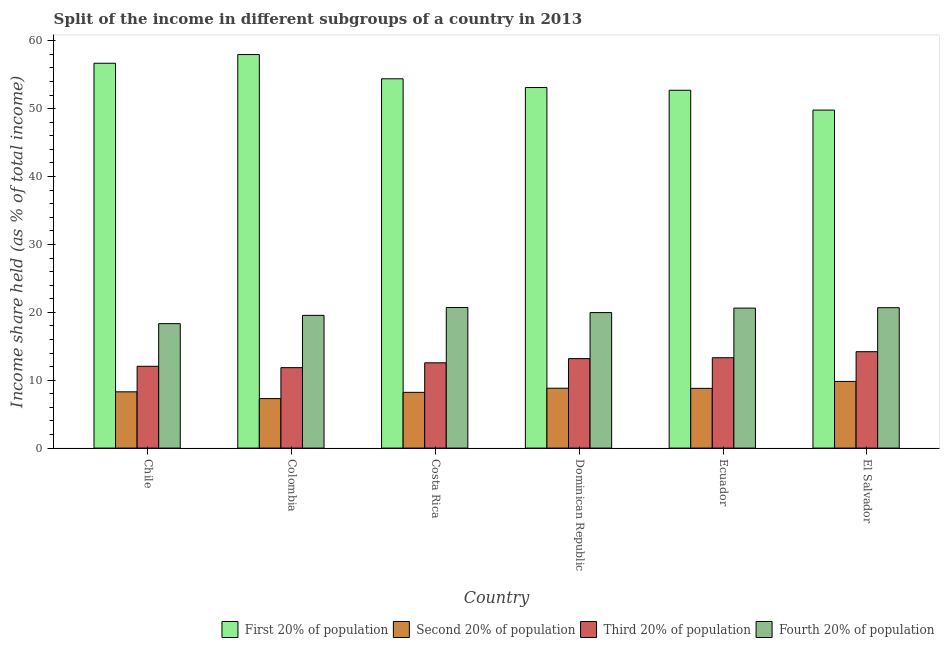Are the number of bars on each tick of the X-axis equal?
Keep it short and to the point. Yes. What is the label of the 4th group of bars from the left?
Ensure brevity in your answer.  Dominican Republic. What is the share of the income held by fourth 20% of the population in Costa Rica?
Ensure brevity in your answer.  20.71. Across all countries, what is the maximum share of the income held by second 20% of the population?
Your answer should be very brief. 9.82. Across all countries, what is the minimum share of the income held by first 20% of the population?
Keep it short and to the point. 49.79. In which country was the share of the income held by second 20% of the population maximum?
Offer a very short reply. El Salvador. What is the total share of the income held by third 20% of the population in the graph?
Provide a succinct answer. 77.15. What is the difference between the share of the income held by third 20% of the population in Ecuador and that in El Salvador?
Provide a short and direct response. -0.89. What is the difference between the share of the income held by first 20% of the population in Costa Rica and the share of the income held by second 20% of the population in El Salvador?
Your answer should be compact. 44.58. What is the average share of the income held by second 20% of the population per country?
Your response must be concise. 8.54. What is the difference between the share of the income held by fourth 20% of the population and share of the income held by first 20% of the population in Chile?
Keep it short and to the point. -38.36. What is the ratio of the share of the income held by third 20% of the population in Chile to that in Colombia?
Offer a terse response. 1.02. What is the difference between the highest and the second highest share of the income held by first 20% of the population?
Your answer should be compact. 1.28. What is the difference between the highest and the lowest share of the income held by third 20% of the population?
Ensure brevity in your answer.  2.35. In how many countries, is the share of the income held by fourth 20% of the population greater than the average share of the income held by fourth 20% of the population taken over all countries?
Your answer should be compact. 3. Is the sum of the share of the income held by second 20% of the population in Costa Rica and Ecuador greater than the maximum share of the income held by third 20% of the population across all countries?
Your answer should be very brief. Yes. Is it the case that in every country, the sum of the share of the income held by second 20% of the population and share of the income held by fourth 20% of the population is greater than the sum of share of the income held by first 20% of the population and share of the income held by third 20% of the population?
Give a very brief answer. Yes. What does the 4th bar from the left in El Salvador represents?
Provide a short and direct response. Fourth 20% of population. What does the 4th bar from the right in Ecuador represents?
Keep it short and to the point. First 20% of population. Is it the case that in every country, the sum of the share of the income held by first 20% of the population and share of the income held by second 20% of the population is greater than the share of the income held by third 20% of the population?
Give a very brief answer. Yes. Are all the bars in the graph horizontal?
Make the answer very short. No. How many countries are there in the graph?
Provide a succinct answer. 6. Does the graph contain any zero values?
Give a very brief answer. No. Does the graph contain grids?
Your answer should be very brief. No. How many legend labels are there?
Provide a short and direct response. 4. What is the title of the graph?
Provide a succinct answer. Split of the income in different subgroups of a country in 2013. What is the label or title of the X-axis?
Offer a very short reply. Country. What is the label or title of the Y-axis?
Provide a succinct answer. Income share held (as % of total income). What is the Income share held (as % of total income) in First 20% of population in Chile?
Ensure brevity in your answer.  56.69. What is the Income share held (as % of total income) of Second 20% of population in Chile?
Ensure brevity in your answer.  8.29. What is the Income share held (as % of total income) of Third 20% of population in Chile?
Ensure brevity in your answer.  12.05. What is the Income share held (as % of total income) of Fourth 20% of population in Chile?
Provide a short and direct response. 18.33. What is the Income share held (as % of total income) of First 20% of population in Colombia?
Offer a terse response. 57.97. What is the Income share held (as % of total income) of Second 20% of population in Colombia?
Your response must be concise. 7.29. What is the Income share held (as % of total income) of Third 20% of population in Colombia?
Provide a short and direct response. 11.85. What is the Income share held (as % of total income) of Fourth 20% of population in Colombia?
Give a very brief answer. 19.55. What is the Income share held (as % of total income) of First 20% of population in Costa Rica?
Ensure brevity in your answer.  54.4. What is the Income share held (as % of total income) in Second 20% of population in Costa Rica?
Your response must be concise. 8.21. What is the Income share held (as % of total income) in Third 20% of population in Costa Rica?
Your answer should be very brief. 12.56. What is the Income share held (as % of total income) of Fourth 20% of population in Costa Rica?
Your answer should be compact. 20.71. What is the Income share held (as % of total income) in First 20% of population in Dominican Republic?
Keep it short and to the point. 53.11. What is the Income share held (as % of total income) in Second 20% of population in Dominican Republic?
Keep it short and to the point. 8.82. What is the Income share held (as % of total income) of Third 20% of population in Dominican Republic?
Ensure brevity in your answer.  13.18. What is the Income share held (as % of total income) in Fourth 20% of population in Dominican Republic?
Give a very brief answer. 19.96. What is the Income share held (as % of total income) of First 20% of population in Ecuador?
Offer a very short reply. 52.71. What is the Income share held (as % of total income) of Third 20% of population in Ecuador?
Give a very brief answer. 13.31. What is the Income share held (as % of total income) in Fourth 20% of population in Ecuador?
Your answer should be compact. 20.62. What is the Income share held (as % of total income) of First 20% of population in El Salvador?
Offer a very short reply. 49.79. What is the Income share held (as % of total income) of Second 20% of population in El Salvador?
Give a very brief answer. 9.82. What is the Income share held (as % of total income) of Fourth 20% of population in El Salvador?
Your response must be concise. 20.68. Across all countries, what is the maximum Income share held (as % of total income) in First 20% of population?
Your answer should be compact. 57.97. Across all countries, what is the maximum Income share held (as % of total income) of Second 20% of population?
Make the answer very short. 9.82. Across all countries, what is the maximum Income share held (as % of total income) in Fourth 20% of population?
Ensure brevity in your answer.  20.71. Across all countries, what is the minimum Income share held (as % of total income) of First 20% of population?
Make the answer very short. 49.79. Across all countries, what is the minimum Income share held (as % of total income) of Second 20% of population?
Ensure brevity in your answer.  7.29. Across all countries, what is the minimum Income share held (as % of total income) of Third 20% of population?
Your answer should be very brief. 11.85. Across all countries, what is the minimum Income share held (as % of total income) of Fourth 20% of population?
Give a very brief answer. 18.33. What is the total Income share held (as % of total income) of First 20% of population in the graph?
Your answer should be very brief. 324.67. What is the total Income share held (as % of total income) of Second 20% of population in the graph?
Give a very brief answer. 51.23. What is the total Income share held (as % of total income) in Third 20% of population in the graph?
Offer a very short reply. 77.15. What is the total Income share held (as % of total income) of Fourth 20% of population in the graph?
Your answer should be very brief. 119.85. What is the difference between the Income share held (as % of total income) of First 20% of population in Chile and that in Colombia?
Give a very brief answer. -1.28. What is the difference between the Income share held (as % of total income) in Third 20% of population in Chile and that in Colombia?
Your answer should be compact. 0.2. What is the difference between the Income share held (as % of total income) of Fourth 20% of population in Chile and that in Colombia?
Your answer should be very brief. -1.22. What is the difference between the Income share held (as % of total income) of First 20% of population in Chile and that in Costa Rica?
Offer a terse response. 2.29. What is the difference between the Income share held (as % of total income) in Second 20% of population in Chile and that in Costa Rica?
Provide a succinct answer. 0.08. What is the difference between the Income share held (as % of total income) in Third 20% of population in Chile and that in Costa Rica?
Provide a succinct answer. -0.51. What is the difference between the Income share held (as % of total income) in Fourth 20% of population in Chile and that in Costa Rica?
Offer a very short reply. -2.38. What is the difference between the Income share held (as % of total income) of First 20% of population in Chile and that in Dominican Republic?
Your answer should be compact. 3.58. What is the difference between the Income share held (as % of total income) of Second 20% of population in Chile and that in Dominican Republic?
Your answer should be very brief. -0.53. What is the difference between the Income share held (as % of total income) in Third 20% of population in Chile and that in Dominican Republic?
Give a very brief answer. -1.13. What is the difference between the Income share held (as % of total income) of Fourth 20% of population in Chile and that in Dominican Republic?
Provide a succinct answer. -1.63. What is the difference between the Income share held (as % of total income) in First 20% of population in Chile and that in Ecuador?
Keep it short and to the point. 3.98. What is the difference between the Income share held (as % of total income) of Second 20% of population in Chile and that in Ecuador?
Your answer should be compact. -0.51. What is the difference between the Income share held (as % of total income) in Third 20% of population in Chile and that in Ecuador?
Your response must be concise. -1.26. What is the difference between the Income share held (as % of total income) in Fourth 20% of population in Chile and that in Ecuador?
Your answer should be compact. -2.29. What is the difference between the Income share held (as % of total income) of Second 20% of population in Chile and that in El Salvador?
Make the answer very short. -1.53. What is the difference between the Income share held (as % of total income) in Third 20% of population in Chile and that in El Salvador?
Offer a very short reply. -2.15. What is the difference between the Income share held (as % of total income) in Fourth 20% of population in Chile and that in El Salvador?
Your answer should be very brief. -2.35. What is the difference between the Income share held (as % of total income) in First 20% of population in Colombia and that in Costa Rica?
Make the answer very short. 3.57. What is the difference between the Income share held (as % of total income) in Second 20% of population in Colombia and that in Costa Rica?
Offer a very short reply. -0.92. What is the difference between the Income share held (as % of total income) of Third 20% of population in Colombia and that in Costa Rica?
Your answer should be compact. -0.71. What is the difference between the Income share held (as % of total income) in Fourth 20% of population in Colombia and that in Costa Rica?
Your response must be concise. -1.16. What is the difference between the Income share held (as % of total income) of First 20% of population in Colombia and that in Dominican Republic?
Offer a very short reply. 4.86. What is the difference between the Income share held (as % of total income) in Second 20% of population in Colombia and that in Dominican Republic?
Provide a succinct answer. -1.53. What is the difference between the Income share held (as % of total income) of Third 20% of population in Colombia and that in Dominican Republic?
Make the answer very short. -1.33. What is the difference between the Income share held (as % of total income) in Fourth 20% of population in Colombia and that in Dominican Republic?
Your answer should be compact. -0.41. What is the difference between the Income share held (as % of total income) in First 20% of population in Colombia and that in Ecuador?
Make the answer very short. 5.26. What is the difference between the Income share held (as % of total income) in Second 20% of population in Colombia and that in Ecuador?
Provide a succinct answer. -1.51. What is the difference between the Income share held (as % of total income) of Third 20% of population in Colombia and that in Ecuador?
Offer a very short reply. -1.46. What is the difference between the Income share held (as % of total income) in Fourth 20% of population in Colombia and that in Ecuador?
Provide a short and direct response. -1.07. What is the difference between the Income share held (as % of total income) of First 20% of population in Colombia and that in El Salvador?
Provide a short and direct response. 8.18. What is the difference between the Income share held (as % of total income) in Second 20% of population in Colombia and that in El Salvador?
Make the answer very short. -2.53. What is the difference between the Income share held (as % of total income) in Third 20% of population in Colombia and that in El Salvador?
Your answer should be compact. -2.35. What is the difference between the Income share held (as % of total income) of Fourth 20% of population in Colombia and that in El Salvador?
Give a very brief answer. -1.13. What is the difference between the Income share held (as % of total income) of First 20% of population in Costa Rica and that in Dominican Republic?
Your answer should be compact. 1.29. What is the difference between the Income share held (as % of total income) in Second 20% of population in Costa Rica and that in Dominican Republic?
Offer a terse response. -0.61. What is the difference between the Income share held (as % of total income) in Third 20% of population in Costa Rica and that in Dominican Republic?
Provide a short and direct response. -0.62. What is the difference between the Income share held (as % of total income) in Fourth 20% of population in Costa Rica and that in Dominican Republic?
Make the answer very short. 0.75. What is the difference between the Income share held (as % of total income) in First 20% of population in Costa Rica and that in Ecuador?
Offer a terse response. 1.69. What is the difference between the Income share held (as % of total income) of Second 20% of population in Costa Rica and that in Ecuador?
Provide a short and direct response. -0.59. What is the difference between the Income share held (as % of total income) in Third 20% of population in Costa Rica and that in Ecuador?
Ensure brevity in your answer.  -0.75. What is the difference between the Income share held (as % of total income) of Fourth 20% of population in Costa Rica and that in Ecuador?
Provide a succinct answer. 0.09. What is the difference between the Income share held (as % of total income) of First 20% of population in Costa Rica and that in El Salvador?
Provide a succinct answer. 4.61. What is the difference between the Income share held (as % of total income) in Second 20% of population in Costa Rica and that in El Salvador?
Offer a terse response. -1.61. What is the difference between the Income share held (as % of total income) in Third 20% of population in Costa Rica and that in El Salvador?
Offer a terse response. -1.64. What is the difference between the Income share held (as % of total income) in First 20% of population in Dominican Republic and that in Ecuador?
Offer a terse response. 0.4. What is the difference between the Income share held (as % of total income) of Second 20% of population in Dominican Republic and that in Ecuador?
Ensure brevity in your answer.  0.02. What is the difference between the Income share held (as % of total income) in Third 20% of population in Dominican Republic and that in Ecuador?
Offer a very short reply. -0.13. What is the difference between the Income share held (as % of total income) in Fourth 20% of population in Dominican Republic and that in Ecuador?
Give a very brief answer. -0.66. What is the difference between the Income share held (as % of total income) of First 20% of population in Dominican Republic and that in El Salvador?
Provide a succinct answer. 3.32. What is the difference between the Income share held (as % of total income) of Third 20% of population in Dominican Republic and that in El Salvador?
Offer a very short reply. -1.02. What is the difference between the Income share held (as % of total income) in Fourth 20% of population in Dominican Republic and that in El Salvador?
Your answer should be compact. -0.72. What is the difference between the Income share held (as % of total income) in First 20% of population in Ecuador and that in El Salvador?
Keep it short and to the point. 2.92. What is the difference between the Income share held (as % of total income) in Second 20% of population in Ecuador and that in El Salvador?
Offer a very short reply. -1.02. What is the difference between the Income share held (as % of total income) in Third 20% of population in Ecuador and that in El Salvador?
Offer a very short reply. -0.89. What is the difference between the Income share held (as % of total income) of Fourth 20% of population in Ecuador and that in El Salvador?
Give a very brief answer. -0.06. What is the difference between the Income share held (as % of total income) of First 20% of population in Chile and the Income share held (as % of total income) of Second 20% of population in Colombia?
Make the answer very short. 49.4. What is the difference between the Income share held (as % of total income) of First 20% of population in Chile and the Income share held (as % of total income) of Third 20% of population in Colombia?
Your response must be concise. 44.84. What is the difference between the Income share held (as % of total income) in First 20% of population in Chile and the Income share held (as % of total income) in Fourth 20% of population in Colombia?
Your answer should be very brief. 37.14. What is the difference between the Income share held (as % of total income) in Second 20% of population in Chile and the Income share held (as % of total income) in Third 20% of population in Colombia?
Provide a succinct answer. -3.56. What is the difference between the Income share held (as % of total income) of Second 20% of population in Chile and the Income share held (as % of total income) of Fourth 20% of population in Colombia?
Offer a very short reply. -11.26. What is the difference between the Income share held (as % of total income) of Third 20% of population in Chile and the Income share held (as % of total income) of Fourth 20% of population in Colombia?
Your response must be concise. -7.5. What is the difference between the Income share held (as % of total income) in First 20% of population in Chile and the Income share held (as % of total income) in Second 20% of population in Costa Rica?
Offer a terse response. 48.48. What is the difference between the Income share held (as % of total income) of First 20% of population in Chile and the Income share held (as % of total income) of Third 20% of population in Costa Rica?
Your answer should be compact. 44.13. What is the difference between the Income share held (as % of total income) in First 20% of population in Chile and the Income share held (as % of total income) in Fourth 20% of population in Costa Rica?
Provide a short and direct response. 35.98. What is the difference between the Income share held (as % of total income) of Second 20% of population in Chile and the Income share held (as % of total income) of Third 20% of population in Costa Rica?
Keep it short and to the point. -4.27. What is the difference between the Income share held (as % of total income) in Second 20% of population in Chile and the Income share held (as % of total income) in Fourth 20% of population in Costa Rica?
Your answer should be very brief. -12.42. What is the difference between the Income share held (as % of total income) in Third 20% of population in Chile and the Income share held (as % of total income) in Fourth 20% of population in Costa Rica?
Your response must be concise. -8.66. What is the difference between the Income share held (as % of total income) of First 20% of population in Chile and the Income share held (as % of total income) of Second 20% of population in Dominican Republic?
Keep it short and to the point. 47.87. What is the difference between the Income share held (as % of total income) of First 20% of population in Chile and the Income share held (as % of total income) of Third 20% of population in Dominican Republic?
Provide a short and direct response. 43.51. What is the difference between the Income share held (as % of total income) in First 20% of population in Chile and the Income share held (as % of total income) in Fourth 20% of population in Dominican Republic?
Provide a succinct answer. 36.73. What is the difference between the Income share held (as % of total income) in Second 20% of population in Chile and the Income share held (as % of total income) in Third 20% of population in Dominican Republic?
Your response must be concise. -4.89. What is the difference between the Income share held (as % of total income) in Second 20% of population in Chile and the Income share held (as % of total income) in Fourth 20% of population in Dominican Republic?
Offer a very short reply. -11.67. What is the difference between the Income share held (as % of total income) of Third 20% of population in Chile and the Income share held (as % of total income) of Fourth 20% of population in Dominican Republic?
Offer a very short reply. -7.91. What is the difference between the Income share held (as % of total income) in First 20% of population in Chile and the Income share held (as % of total income) in Second 20% of population in Ecuador?
Make the answer very short. 47.89. What is the difference between the Income share held (as % of total income) in First 20% of population in Chile and the Income share held (as % of total income) in Third 20% of population in Ecuador?
Ensure brevity in your answer.  43.38. What is the difference between the Income share held (as % of total income) in First 20% of population in Chile and the Income share held (as % of total income) in Fourth 20% of population in Ecuador?
Keep it short and to the point. 36.07. What is the difference between the Income share held (as % of total income) of Second 20% of population in Chile and the Income share held (as % of total income) of Third 20% of population in Ecuador?
Your response must be concise. -5.02. What is the difference between the Income share held (as % of total income) of Second 20% of population in Chile and the Income share held (as % of total income) of Fourth 20% of population in Ecuador?
Provide a short and direct response. -12.33. What is the difference between the Income share held (as % of total income) of Third 20% of population in Chile and the Income share held (as % of total income) of Fourth 20% of population in Ecuador?
Your response must be concise. -8.57. What is the difference between the Income share held (as % of total income) of First 20% of population in Chile and the Income share held (as % of total income) of Second 20% of population in El Salvador?
Your answer should be compact. 46.87. What is the difference between the Income share held (as % of total income) in First 20% of population in Chile and the Income share held (as % of total income) in Third 20% of population in El Salvador?
Provide a short and direct response. 42.49. What is the difference between the Income share held (as % of total income) in First 20% of population in Chile and the Income share held (as % of total income) in Fourth 20% of population in El Salvador?
Offer a terse response. 36.01. What is the difference between the Income share held (as % of total income) of Second 20% of population in Chile and the Income share held (as % of total income) of Third 20% of population in El Salvador?
Your answer should be very brief. -5.91. What is the difference between the Income share held (as % of total income) of Second 20% of population in Chile and the Income share held (as % of total income) of Fourth 20% of population in El Salvador?
Your answer should be very brief. -12.39. What is the difference between the Income share held (as % of total income) in Third 20% of population in Chile and the Income share held (as % of total income) in Fourth 20% of population in El Salvador?
Provide a succinct answer. -8.63. What is the difference between the Income share held (as % of total income) in First 20% of population in Colombia and the Income share held (as % of total income) in Second 20% of population in Costa Rica?
Provide a short and direct response. 49.76. What is the difference between the Income share held (as % of total income) of First 20% of population in Colombia and the Income share held (as % of total income) of Third 20% of population in Costa Rica?
Offer a terse response. 45.41. What is the difference between the Income share held (as % of total income) in First 20% of population in Colombia and the Income share held (as % of total income) in Fourth 20% of population in Costa Rica?
Give a very brief answer. 37.26. What is the difference between the Income share held (as % of total income) of Second 20% of population in Colombia and the Income share held (as % of total income) of Third 20% of population in Costa Rica?
Keep it short and to the point. -5.27. What is the difference between the Income share held (as % of total income) of Second 20% of population in Colombia and the Income share held (as % of total income) of Fourth 20% of population in Costa Rica?
Ensure brevity in your answer.  -13.42. What is the difference between the Income share held (as % of total income) of Third 20% of population in Colombia and the Income share held (as % of total income) of Fourth 20% of population in Costa Rica?
Ensure brevity in your answer.  -8.86. What is the difference between the Income share held (as % of total income) in First 20% of population in Colombia and the Income share held (as % of total income) in Second 20% of population in Dominican Republic?
Provide a succinct answer. 49.15. What is the difference between the Income share held (as % of total income) of First 20% of population in Colombia and the Income share held (as % of total income) of Third 20% of population in Dominican Republic?
Offer a very short reply. 44.79. What is the difference between the Income share held (as % of total income) of First 20% of population in Colombia and the Income share held (as % of total income) of Fourth 20% of population in Dominican Republic?
Your response must be concise. 38.01. What is the difference between the Income share held (as % of total income) of Second 20% of population in Colombia and the Income share held (as % of total income) of Third 20% of population in Dominican Republic?
Your answer should be very brief. -5.89. What is the difference between the Income share held (as % of total income) of Second 20% of population in Colombia and the Income share held (as % of total income) of Fourth 20% of population in Dominican Republic?
Give a very brief answer. -12.67. What is the difference between the Income share held (as % of total income) of Third 20% of population in Colombia and the Income share held (as % of total income) of Fourth 20% of population in Dominican Republic?
Offer a very short reply. -8.11. What is the difference between the Income share held (as % of total income) in First 20% of population in Colombia and the Income share held (as % of total income) in Second 20% of population in Ecuador?
Your answer should be compact. 49.17. What is the difference between the Income share held (as % of total income) of First 20% of population in Colombia and the Income share held (as % of total income) of Third 20% of population in Ecuador?
Your response must be concise. 44.66. What is the difference between the Income share held (as % of total income) of First 20% of population in Colombia and the Income share held (as % of total income) of Fourth 20% of population in Ecuador?
Provide a short and direct response. 37.35. What is the difference between the Income share held (as % of total income) in Second 20% of population in Colombia and the Income share held (as % of total income) in Third 20% of population in Ecuador?
Offer a terse response. -6.02. What is the difference between the Income share held (as % of total income) of Second 20% of population in Colombia and the Income share held (as % of total income) of Fourth 20% of population in Ecuador?
Your answer should be compact. -13.33. What is the difference between the Income share held (as % of total income) of Third 20% of population in Colombia and the Income share held (as % of total income) of Fourth 20% of population in Ecuador?
Provide a short and direct response. -8.77. What is the difference between the Income share held (as % of total income) of First 20% of population in Colombia and the Income share held (as % of total income) of Second 20% of population in El Salvador?
Your response must be concise. 48.15. What is the difference between the Income share held (as % of total income) of First 20% of population in Colombia and the Income share held (as % of total income) of Third 20% of population in El Salvador?
Ensure brevity in your answer.  43.77. What is the difference between the Income share held (as % of total income) of First 20% of population in Colombia and the Income share held (as % of total income) of Fourth 20% of population in El Salvador?
Your answer should be compact. 37.29. What is the difference between the Income share held (as % of total income) in Second 20% of population in Colombia and the Income share held (as % of total income) in Third 20% of population in El Salvador?
Keep it short and to the point. -6.91. What is the difference between the Income share held (as % of total income) of Second 20% of population in Colombia and the Income share held (as % of total income) of Fourth 20% of population in El Salvador?
Ensure brevity in your answer.  -13.39. What is the difference between the Income share held (as % of total income) in Third 20% of population in Colombia and the Income share held (as % of total income) in Fourth 20% of population in El Salvador?
Give a very brief answer. -8.83. What is the difference between the Income share held (as % of total income) of First 20% of population in Costa Rica and the Income share held (as % of total income) of Second 20% of population in Dominican Republic?
Your response must be concise. 45.58. What is the difference between the Income share held (as % of total income) in First 20% of population in Costa Rica and the Income share held (as % of total income) in Third 20% of population in Dominican Republic?
Offer a terse response. 41.22. What is the difference between the Income share held (as % of total income) of First 20% of population in Costa Rica and the Income share held (as % of total income) of Fourth 20% of population in Dominican Republic?
Provide a succinct answer. 34.44. What is the difference between the Income share held (as % of total income) of Second 20% of population in Costa Rica and the Income share held (as % of total income) of Third 20% of population in Dominican Republic?
Make the answer very short. -4.97. What is the difference between the Income share held (as % of total income) in Second 20% of population in Costa Rica and the Income share held (as % of total income) in Fourth 20% of population in Dominican Republic?
Your response must be concise. -11.75. What is the difference between the Income share held (as % of total income) in Third 20% of population in Costa Rica and the Income share held (as % of total income) in Fourth 20% of population in Dominican Republic?
Give a very brief answer. -7.4. What is the difference between the Income share held (as % of total income) of First 20% of population in Costa Rica and the Income share held (as % of total income) of Second 20% of population in Ecuador?
Offer a very short reply. 45.6. What is the difference between the Income share held (as % of total income) in First 20% of population in Costa Rica and the Income share held (as % of total income) in Third 20% of population in Ecuador?
Keep it short and to the point. 41.09. What is the difference between the Income share held (as % of total income) of First 20% of population in Costa Rica and the Income share held (as % of total income) of Fourth 20% of population in Ecuador?
Make the answer very short. 33.78. What is the difference between the Income share held (as % of total income) in Second 20% of population in Costa Rica and the Income share held (as % of total income) in Third 20% of population in Ecuador?
Your answer should be very brief. -5.1. What is the difference between the Income share held (as % of total income) in Second 20% of population in Costa Rica and the Income share held (as % of total income) in Fourth 20% of population in Ecuador?
Provide a short and direct response. -12.41. What is the difference between the Income share held (as % of total income) in Third 20% of population in Costa Rica and the Income share held (as % of total income) in Fourth 20% of population in Ecuador?
Offer a terse response. -8.06. What is the difference between the Income share held (as % of total income) of First 20% of population in Costa Rica and the Income share held (as % of total income) of Second 20% of population in El Salvador?
Provide a short and direct response. 44.58. What is the difference between the Income share held (as % of total income) of First 20% of population in Costa Rica and the Income share held (as % of total income) of Third 20% of population in El Salvador?
Your answer should be compact. 40.2. What is the difference between the Income share held (as % of total income) of First 20% of population in Costa Rica and the Income share held (as % of total income) of Fourth 20% of population in El Salvador?
Your answer should be compact. 33.72. What is the difference between the Income share held (as % of total income) of Second 20% of population in Costa Rica and the Income share held (as % of total income) of Third 20% of population in El Salvador?
Your answer should be compact. -5.99. What is the difference between the Income share held (as % of total income) of Second 20% of population in Costa Rica and the Income share held (as % of total income) of Fourth 20% of population in El Salvador?
Provide a short and direct response. -12.47. What is the difference between the Income share held (as % of total income) of Third 20% of population in Costa Rica and the Income share held (as % of total income) of Fourth 20% of population in El Salvador?
Give a very brief answer. -8.12. What is the difference between the Income share held (as % of total income) of First 20% of population in Dominican Republic and the Income share held (as % of total income) of Second 20% of population in Ecuador?
Ensure brevity in your answer.  44.31. What is the difference between the Income share held (as % of total income) in First 20% of population in Dominican Republic and the Income share held (as % of total income) in Third 20% of population in Ecuador?
Make the answer very short. 39.8. What is the difference between the Income share held (as % of total income) in First 20% of population in Dominican Republic and the Income share held (as % of total income) in Fourth 20% of population in Ecuador?
Offer a terse response. 32.49. What is the difference between the Income share held (as % of total income) in Second 20% of population in Dominican Republic and the Income share held (as % of total income) in Third 20% of population in Ecuador?
Provide a short and direct response. -4.49. What is the difference between the Income share held (as % of total income) of Third 20% of population in Dominican Republic and the Income share held (as % of total income) of Fourth 20% of population in Ecuador?
Make the answer very short. -7.44. What is the difference between the Income share held (as % of total income) of First 20% of population in Dominican Republic and the Income share held (as % of total income) of Second 20% of population in El Salvador?
Offer a terse response. 43.29. What is the difference between the Income share held (as % of total income) of First 20% of population in Dominican Republic and the Income share held (as % of total income) of Third 20% of population in El Salvador?
Ensure brevity in your answer.  38.91. What is the difference between the Income share held (as % of total income) in First 20% of population in Dominican Republic and the Income share held (as % of total income) in Fourth 20% of population in El Salvador?
Offer a very short reply. 32.43. What is the difference between the Income share held (as % of total income) of Second 20% of population in Dominican Republic and the Income share held (as % of total income) of Third 20% of population in El Salvador?
Make the answer very short. -5.38. What is the difference between the Income share held (as % of total income) of Second 20% of population in Dominican Republic and the Income share held (as % of total income) of Fourth 20% of population in El Salvador?
Provide a short and direct response. -11.86. What is the difference between the Income share held (as % of total income) in Third 20% of population in Dominican Republic and the Income share held (as % of total income) in Fourth 20% of population in El Salvador?
Your answer should be compact. -7.5. What is the difference between the Income share held (as % of total income) in First 20% of population in Ecuador and the Income share held (as % of total income) in Second 20% of population in El Salvador?
Make the answer very short. 42.89. What is the difference between the Income share held (as % of total income) in First 20% of population in Ecuador and the Income share held (as % of total income) in Third 20% of population in El Salvador?
Keep it short and to the point. 38.51. What is the difference between the Income share held (as % of total income) of First 20% of population in Ecuador and the Income share held (as % of total income) of Fourth 20% of population in El Salvador?
Give a very brief answer. 32.03. What is the difference between the Income share held (as % of total income) of Second 20% of population in Ecuador and the Income share held (as % of total income) of Fourth 20% of population in El Salvador?
Offer a very short reply. -11.88. What is the difference between the Income share held (as % of total income) of Third 20% of population in Ecuador and the Income share held (as % of total income) of Fourth 20% of population in El Salvador?
Your response must be concise. -7.37. What is the average Income share held (as % of total income) of First 20% of population per country?
Your answer should be very brief. 54.11. What is the average Income share held (as % of total income) in Second 20% of population per country?
Your response must be concise. 8.54. What is the average Income share held (as % of total income) in Third 20% of population per country?
Offer a very short reply. 12.86. What is the average Income share held (as % of total income) of Fourth 20% of population per country?
Ensure brevity in your answer.  19.98. What is the difference between the Income share held (as % of total income) of First 20% of population and Income share held (as % of total income) of Second 20% of population in Chile?
Ensure brevity in your answer.  48.4. What is the difference between the Income share held (as % of total income) of First 20% of population and Income share held (as % of total income) of Third 20% of population in Chile?
Offer a very short reply. 44.64. What is the difference between the Income share held (as % of total income) in First 20% of population and Income share held (as % of total income) in Fourth 20% of population in Chile?
Give a very brief answer. 38.36. What is the difference between the Income share held (as % of total income) of Second 20% of population and Income share held (as % of total income) of Third 20% of population in Chile?
Offer a very short reply. -3.76. What is the difference between the Income share held (as % of total income) of Second 20% of population and Income share held (as % of total income) of Fourth 20% of population in Chile?
Provide a succinct answer. -10.04. What is the difference between the Income share held (as % of total income) of Third 20% of population and Income share held (as % of total income) of Fourth 20% of population in Chile?
Give a very brief answer. -6.28. What is the difference between the Income share held (as % of total income) in First 20% of population and Income share held (as % of total income) in Second 20% of population in Colombia?
Your response must be concise. 50.68. What is the difference between the Income share held (as % of total income) of First 20% of population and Income share held (as % of total income) of Third 20% of population in Colombia?
Give a very brief answer. 46.12. What is the difference between the Income share held (as % of total income) in First 20% of population and Income share held (as % of total income) in Fourth 20% of population in Colombia?
Provide a succinct answer. 38.42. What is the difference between the Income share held (as % of total income) in Second 20% of population and Income share held (as % of total income) in Third 20% of population in Colombia?
Provide a succinct answer. -4.56. What is the difference between the Income share held (as % of total income) in Second 20% of population and Income share held (as % of total income) in Fourth 20% of population in Colombia?
Your answer should be compact. -12.26. What is the difference between the Income share held (as % of total income) in Third 20% of population and Income share held (as % of total income) in Fourth 20% of population in Colombia?
Keep it short and to the point. -7.7. What is the difference between the Income share held (as % of total income) in First 20% of population and Income share held (as % of total income) in Second 20% of population in Costa Rica?
Your response must be concise. 46.19. What is the difference between the Income share held (as % of total income) of First 20% of population and Income share held (as % of total income) of Third 20% of population in Costa Rica?
Offer a very short reply. 41.84. What is the difference between the Income share held (as % of total income) of First 20% of population and Income share held (as % of total income) of Fourth 20% of population in Costa Rica?
Provide a succinct answer. 33.69. What is the difference between the Income share held (as % of total income) in Second 20% of population and Income share held (as % of total income) in Third 20% of population in Costa Rica?
Your answer should be very brief. -4.35. What is the difference between the Income share held (as % of total income) of Third 20% of population and Income share held (as % of total income) of Fourth 20% of population in Costa Rica?
Offer a very short reply. -8.15. What is the difference between the Income share held (as % of total income) in First 20% of population and Income share held (as % of total income) in Second 20% of population in Dominican Republic?
Your response must be concise. 44.29. What is the difference between the Income share held (as % of total income) in First 20% of population and Income share held (as % of total income) in Third 20% of population in Dominican Republic?
Provide a short and direct response. 39.93. What is the difference between the Income share held (as % of total income) in First 20% of population and Income share held (as % of total income) in Fourth 20% of population in Dominican Republic?
Your answer should be compact. 33.15. What is the difference between the Income share held (as % of total income) in Second 20% of population and Income share held (as % of total income) in Third 20% of population in Dominican Republic?
Your answer should be very brief. -4.36. What is the difference between the Income share held (as % of total income) of Second 20% of population and Income share held (as % of total income) of Fourth 20% of population in Dominican Republic?
Your answer should be compact. -11.14. What is the difference between the Income share held (as % of total income) in Third 20% of population and Income share held (as % of total income) in Fourth 20% of population in Dominican Republic?
Provide a succinct answer. -6.78. What is the difference between the Income share held (as % of total income) in First 20% of population and Income share held (as % of total income) in Second 20% of population in Ecuador?
Your answer should be compact. 43.91. What is the difference between the Income share held (as % of total income) in First 20% of population and Income share held (as % of total income) in Third 20% of population in Ecuador?
Make the answer very short. 39.4. What is the difference between the Income share held (as % of total income) in First 20% of population and Income share held (as % of total income) in Fourth 20% of population in Ecuador?
Keep it short and to the point. 32.09. What is the difference between the Income share held (as % of total income) of Second 20% of population and Income share held (as % of total income) of Third 20% of population in Ecuador?
Provide a short and direct response. -4.51. What is the difference between the Income share held (as % of total income) in Second 20% of population and Income share held (as % of total income) in Fourth 20% of population in Ecuador?
Your response must be concise. -11.82. What is the difference between the Income share held (as % of total income) of Third 20% of population and Income share held (as % of total income) of Fourth 20% of population in Ecuador?
Ensure brevity in your answer.  -7.31. What is the difference between the Income share held (as % of total income) in First 20% of population and Income share held (as % of total income) in Second 20% of population in El Salvador?
Give a very brief answer. 39.97. What is the difference between the Income share held (as % of total income) of First 20% of population and Income share held (as % of total income) of Third 20% of population in El Salvador?
Keep it short and to the point. 35.59. What is the difference between the Income share held (as % of total income) of First 20% of population and Income share held (as % of total income) of Fourth 20% of population in El Salvador?
Offer a terse response. 29.11. What is the difference between the Income share held (as % of total income) in Second 20% of population and Income share held (as % of total income) in Third 20% of population in El Salvador?
Ensure brevity in your answer.  -4.38. What is the difference between the Income share held (as % of total income) of Second 20% of population and Income share held (as % of total income) of Fourth 20% of population in El Salvador?
Provide a succinct answer. -10.86. What is the difference between the Income share held (as % of total income) of Third 20% of population and Income share held (as % of total income) of Fourth 20% of population in El Salvador?
Ensure brevity in your answer.  -6.48. What is the ratio of the Income share held (as % of total income) of First 20% of population in Chile to that in Colombia?
Keep it short and to the point. 0.98. What is the ratio of the Income share held (as % of total income) in Second 20% of population in Chile to that in Colombia?
Give a very brief answer. 1.14. What is the ratio of the Income share held (as % of total income) in Third 20% of population in Chile to that in Colombia?
Your answer should be compact. 1.02. What is the ratio of the Income share held (as % of total income) of Fourth 20% of population in Chile to that in Colombia?
Provide a succinct answer. 0.94. What is the ratio of the Income share held (as % of total income) of First 20% of population in Chile to that in Costa Rica?
Your response must be concise. 1.04. What is the ratio of the Income share held (as % of total income) of Second 20% of population in Chile to that in Costa Rica?
Provide a short and direct response. 1.01. What is the ratio of the Income share held (as % of total income) of Third 20% of population in Chile to that in Costa Rica?
Your response must be concise. 0.96. What is the ratio of the Income share held (as % of total income) of Fourth 20% of population in Chile to that in Costa Rica?
Offer a terse response. 0.89. What is the ratio of the Income share held (as % of total income) of First 20% of population in Chile to that in Dominican Republic?
Provide a short and direct response. 1.07. What is the ratio of the Income share held (as % of total income) of Second 20% of population in Chile to that in Dominican Republic?
Provide a short and direct response. 0.94. What is the ratio of the Income share held (as % of total income) in Third 20% of population in Chile to that in Dominican Republic?
Give a very brief answer. 0.91. What is the ratio of the Income share held (as % of total income) in Fourth 20% of population in Chile to that in Dominican Republic?
Provide a short and direct response. 0.92. What is the ratio of the Income share held (as % of total income) in First 20% of population in Chile to that in Ecuador?
Your answer should be very brief. 1.08. What is the ratio of the Income share held (as % of total income) in Second 20% of population in Chile to that in Ecuador?
Provide a succinct answer. 0.94. What is the ratio of the Income share held (as % of total income) in Third 20% of population in Chile to that in Ecuador?
Keep it short and to the point. 0.91. What is the ratio of the Income share held (as % of total income) of First 20% of population in Chile to that in El Salvador?
Keep it short and to the point. 1.14. What is the ratio of the Income share held (as % of total income) of Second 20% of population in Chile to that in El Salvador?
Keep it short and to the point. 0.84. What is the ratio of the Income share held (as % of total income) of Third 20% of population in Chile to that in El Salvador?
Ensure brevity in your answer.  0.85. What is the ratio of the Income share held (as % of total income) in Fourth 20% of population in Chile to that in El Salvador?
Your response must be concise. 0.89. What is the ratio of the Income share held (as % of total income) in First 20% of population in Colombia to that in Costa Rica?
Your response must be concise. 1.07. What is the ratio of the Income share held (as % of total income) of Second 20% of population in Colombia to that in Costa Rica?
Keep it short and to the point. 0.89. What is the ratio of the Income share held (as % of total income) of Third 20% of population in Colombia to that in Costa Rica?
Provide a succinct answer. 0.94. What is the ratio of the Income share held (as % of total income) of Fourth 20% of population in Colombia to that in Costa Rica?
Provide a short and direct response. 0.94. What is the ratio of the Income share held (as % of total income) of First 20% of population in Colombia to that in Dominican Republic?
Your answer should be very brief. 1.09. What is the ratio of the Income share held (as % of total income) of Second 20% of population in Colombia to that in Dominican Republic?
Keep it short and to the point. 0.83. What is the ratio of the Income share held (as % of total income) of Third 20% of population in Colombia to that in Dominican Republic?
Your answer should be very brief. 0.9. What is the ratio of the Income share held (as % of total income) of Fourth 20% of population in Colombia to that in Dominican Republic?
Provide a short and direct response. 0.98. What is the ratio of the Income share held (as % of total income) in First 20% of population in Colombia to that in Ecuador?
Keep it short and to the point. 1.1. What is the ratio of the Income share held (as % of total income) of Second 20% of population in Colombia to that in Ecuador?
Give a very brief answer. 0.83. What is the ratio of the Income share held (as % of total income) in Third 20% of population in Colombia to that in Ecuador?
Your answer should be very brief. 0.89. What is the ratio of the Income share held (as % of total income) of Fourth 20% of population in Colombia to that in Ecuador?
Your response must be concise. 0.95. What is the ratio of the Income share held (as % of total income) of First 20% of population in Colombia to that in El Salvador?
Offer a very short reply. 1.16. What is the ratio of the Income share held (as % of total income) in Second 20% of population in Colombia to that in El Salvador?
Keep it short and to the point. 0.74. What is the ratio of the Income share held (as % of total income) of Third 20% of population in Colombia to that in El Salvador?
Ensure brevity in your answer.  0.83. What is the ratio of the Income share held (as % of total income) in Fourth 20% of population in Colombia to that in El Salvador?
Keep it short and to the point. 0.95. What is the ratio of the Income share held (as % of total income) of First 20% of population in Costa Rica to that in Dominican Republic?
Your answer should be compact. 1.02. What is the ratio of the Income share held (as % of total income) in Second 20% of population in Costa Rica to that in Dominican Republic?
Provide a short and direct response. 0.93. What is the ratio of the Income share held (as % of total income) in Third 20% of population in Costa Rica to that in Dominican Republic?
Offer a terse response. 0.95. What is the ratio of the Income share held (as % of total income) of Fourth 20% of population in Costa Rica to that in Dominican Republic?
Provide a succinct answer. 1.04. What is the ratio of the Income share held (as % of total income) of First 20% of population in Costa Rica to that in Ecuador?
Provide a short and direct response. 1.03. What is the ratio of the Income share held (as % of total income) of Second 20% of population in Costa Rica to that in Ecuador?
Offer a very short reply. 0.93. What is the ratio of the Income share held (as % of total income) in Third 20% of population in Costa Rica to that in Ecuador?
Your response must be concise. 0.94. What is the ratio of the Income share held (as % of total income) of Fourth 20% of population in Costa Rica to that in Ecuador?
Make the answer very short. 1. What is the ratio of the Income share held (as % of total income) of First 20% of population in Costa Rica to that in El Salvador?
Keep it short and to the point. 1.09. What is the ratio of the Income share held (as % of total income) of Second 20% of population in Costa Rica to that in El Salvador?
Provide a short and direct response. 0.84. What is the ratio of the Income share held (as % of total income) of Third 20% of population in Costa Rica to that in El Salvador?
Your answer should be very brief. 0.88. What is the ratio of the Income share held (as % of total income) of First 20% of population in Dominican Republic to that in Ecuador?
Give a very brief answer. 1.01. What is the ratio of the Income share held (as % of total income) of Second 20% of population in Dominican Republic to that in Ecuador?
Your answer should be compact. 1. What is the ratio of the Income share held (as % of total income) of Third 20% of population in Dominican Republic to that in Ecuador?
Make the answer very short. 0.99. What is the ratio of the Income share held (as % of total income) in First 20% of population in Dominican Republic to that in El Salvador?
Your answer should be compact. 1.07. What is the ratio of the Income share held (as % of total income) of Second 20% of population in Dominican Republic to that in El Salvador?
Ensure brevity in your answer.  0.9. What is the ratio of the Income share held (as % of total income) in Third 20% of population in Dominican Republic to that in El Salvador?
Your answer should be compact. 0.93. What is the ratio of the Income share held (as % of total income) of Fourth 20% of population in Dominican Republic to that in El Salvador?
Provide a succinct answer. 0.97. What is the ratio of the Income share held (as % of total income) in First 20% of population in Ecuador to that in El Salvador?
Offer a terse response. 1.06. What is the ratio of the Income share held (as % of total income) of Second 20% of population in Ecuador to that in El Salvador?
Offer a terse response. 0.9. What is the ratio of the Income share held (as % of total income) in Third 20% of population in Ecuador to that in El Salvador?
Offer a very short reply. 0.94. What is the difference between the highest and the second highest Income share held (as % of total income) in First 20% of population?
Provide a succinct answer. 1.28. What is the difference between the highest and the second highest Income share held (as % of total income) in Third 20% of population?
Your answer should be very brief. 0.89. What is the difference between the highest and the lowest Income share held (as % of total income) in First 20% of population?
Your answer should be compact. 8.18. What is the difference between the highest and the lowest Income share held (as % of total income) of Second 20% of population?
Your answer should be compact. 2.53. What is the difference between the highest and the lowest Income share held (as % of total income) of Third 20% of population?
Your answer should be very brief. 2.35. What is the difference between the highest and the lowest Income share held (as % of total income) in Fourth 20% of population?
Give a very brief answer. 2.38. 